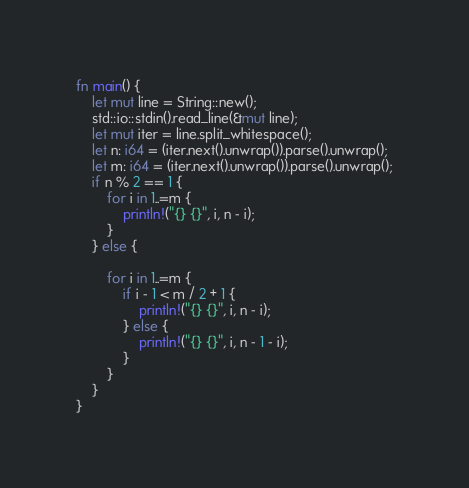Convert code to text. <code><loc_0><loc_0><loc_500><loc_500><_Rust_>
fn main() {
    let mut line = String::new();
    std::io::stdin().read_line(&mut line);
    let mut iter = line.split_whitespace();
    let n: i64 = (iter.next().unwrap()).parse().unwrap();
    let m: i64 = (iter.next().unwrap()).parse().unwrap();
    if n % 2 == 1 {
        for i in 1..=m {
            println!("{} {}", i, n - i);
        }
    } else {

        for i in 1..=m {
            if i - 1 < m / 2 + 1 {
                println!("{} {}", i, n - i);
            } else {
                println!("{} {}", i, n - 1 - i);
            }
        }
    }
}
</code> 